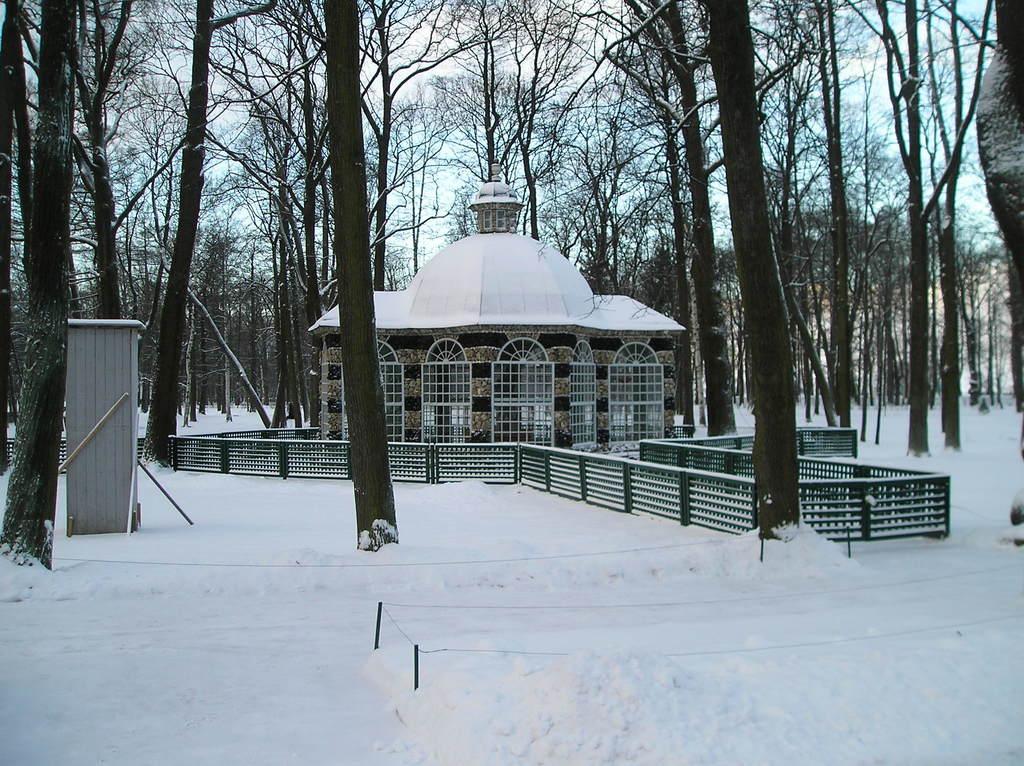Please provide a concise description of this image. This picture shows building and we see trees and snow no on the ground and we see a cloudy Sky. 